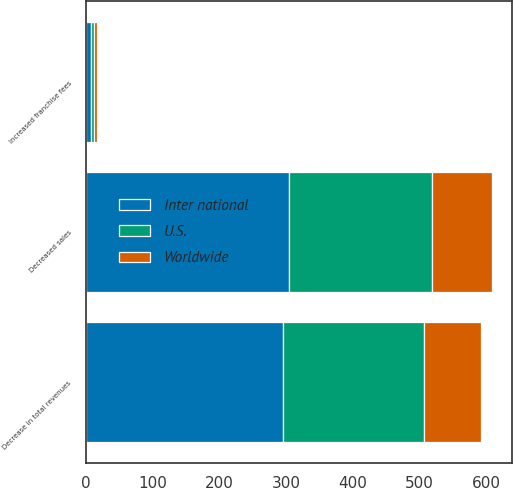<chart> <loc_0><loc_0><loc_500><loc_500><stacked_bar_chart><ecel><fcel>Decreased sales<fcel>Increased franchise fees<fcel>Decrease in total revenues<nl><fcel>U.S.<fcel>214<fcel>4<fcel>210<nl><fcel>Worldwide<fcel>90<fcel>4<fcel>86<nl><fcel>Inter national<fcel>304<fcel>8<fcel>296<nl></chart> 